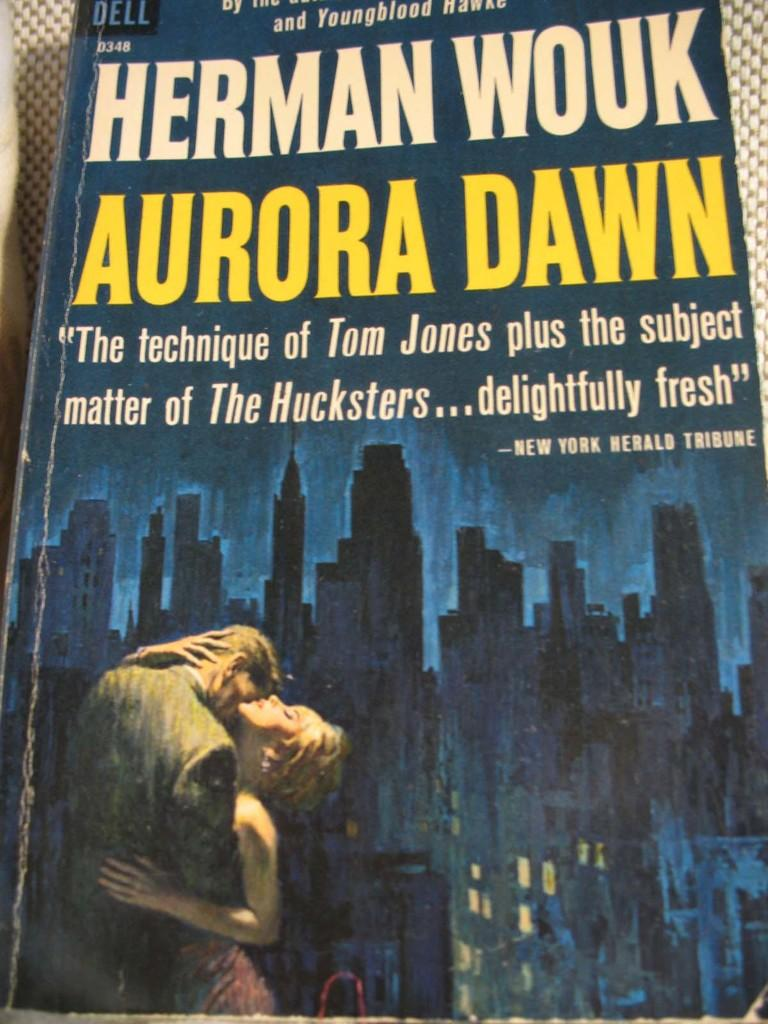<image>
Present a compact description of the photo's key features. A blue book from Herman Wouk, titled Aurora Dawn. 